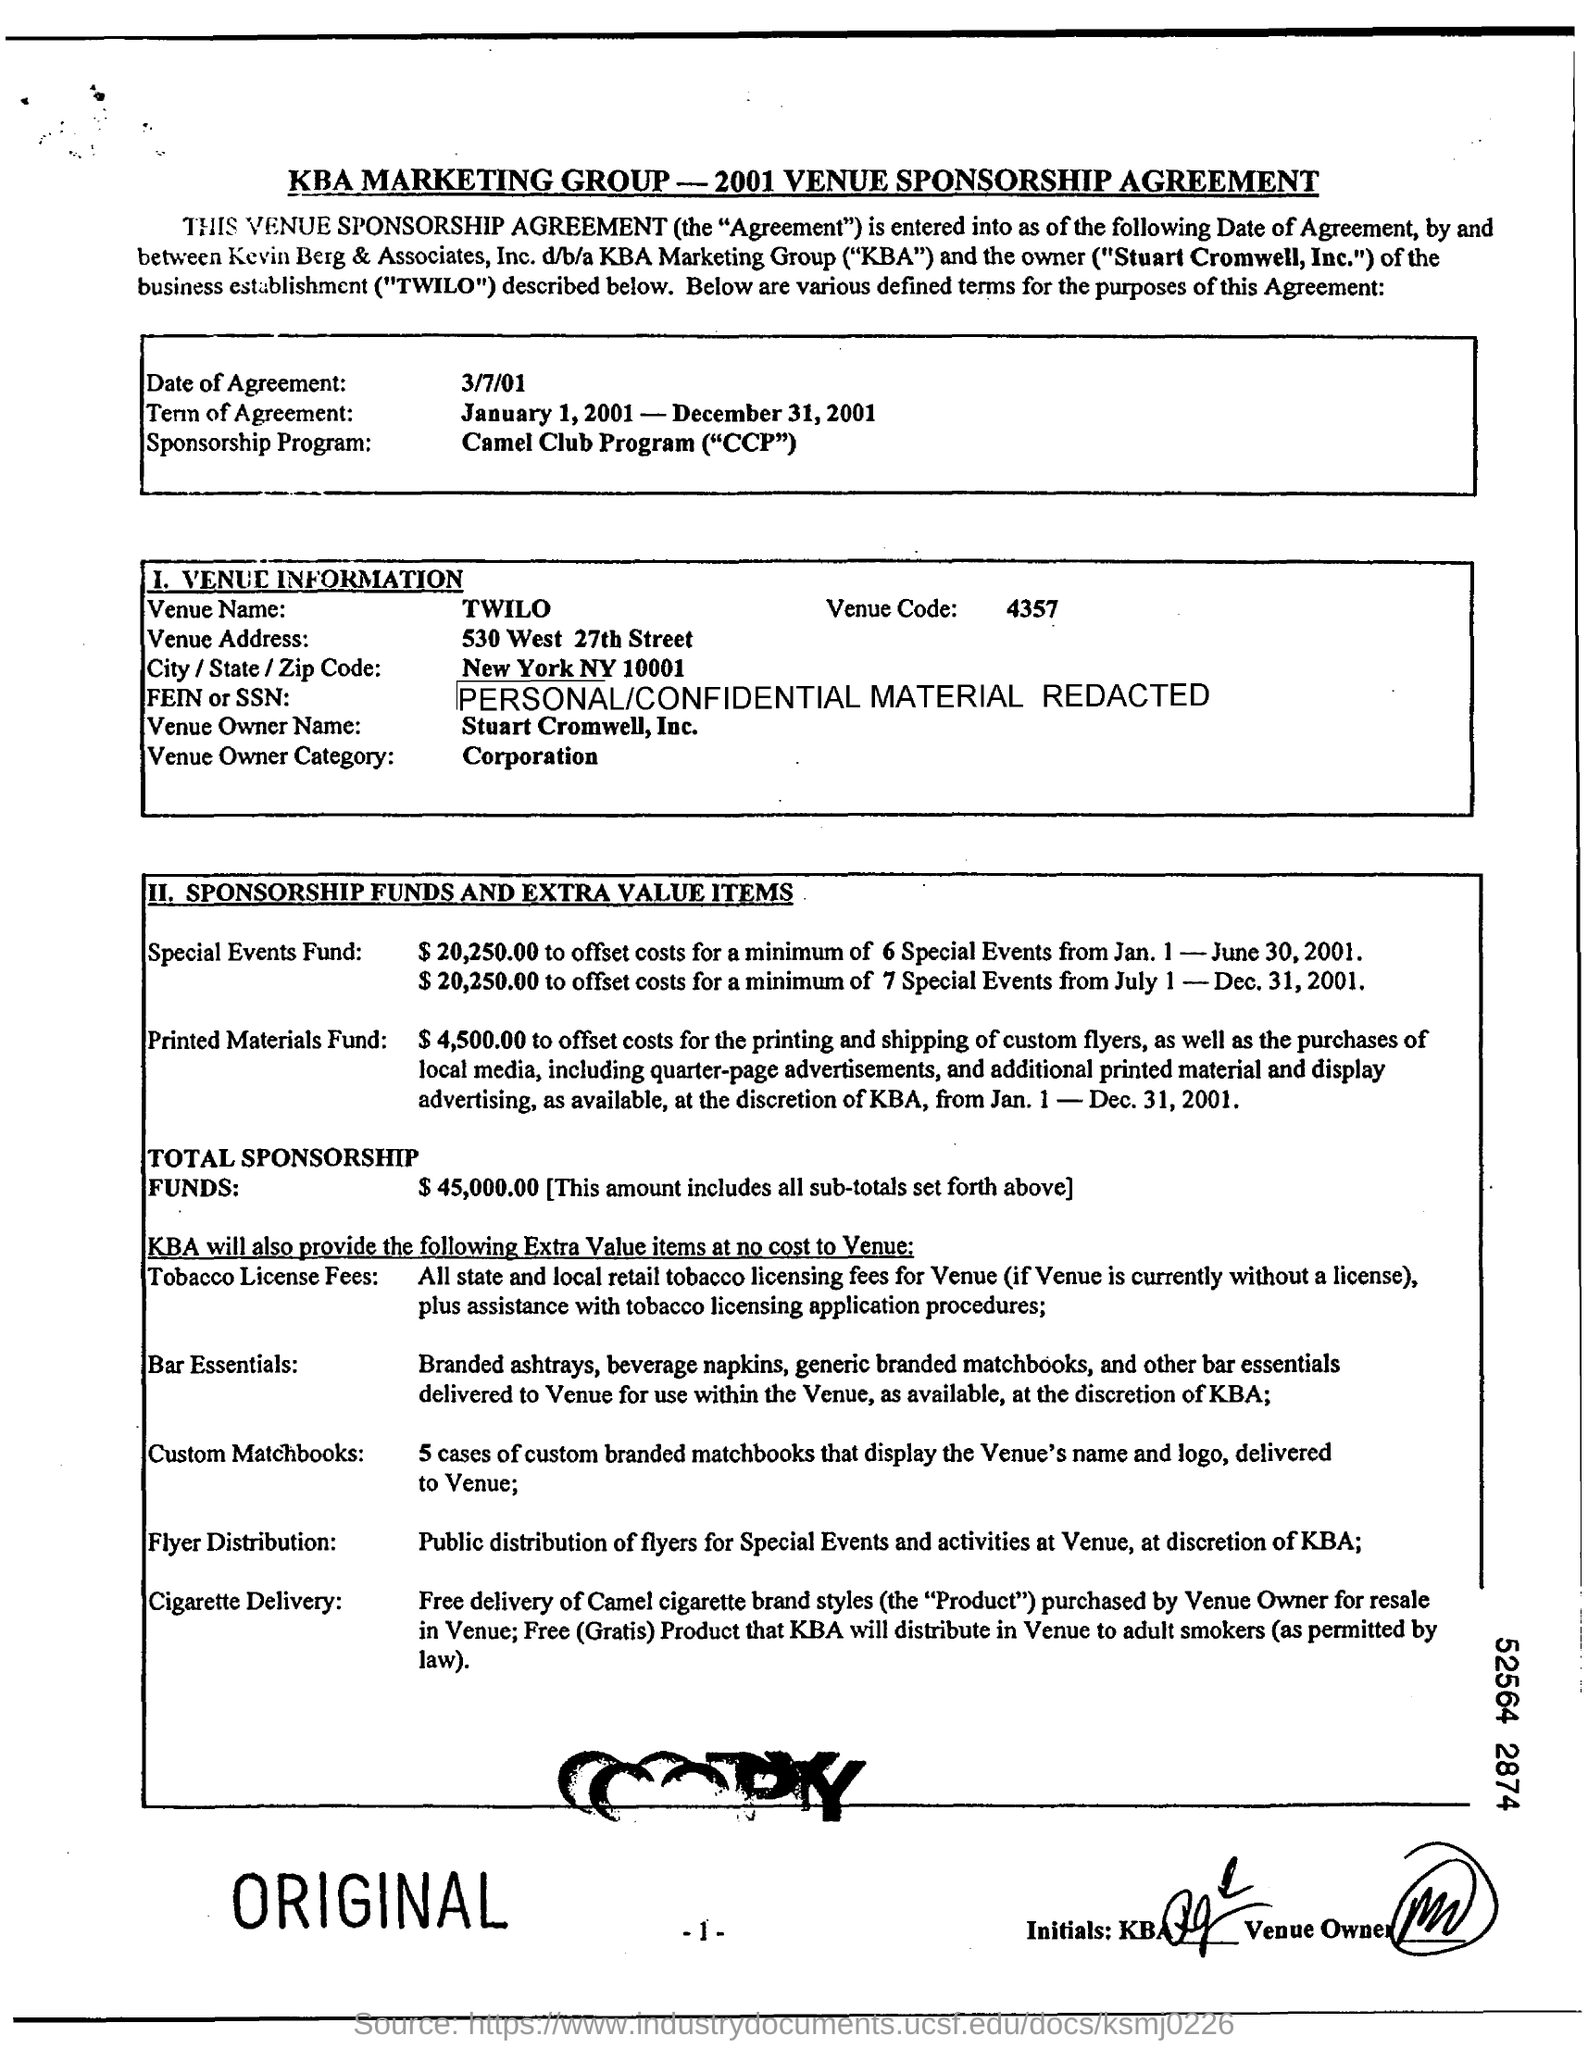Specify some key components in this picture. The total amount of sponsorship funds was $45,000.00. The venue code is 4357. The term of agreement started on January 1, 2001 and ended on December 31, 2001. The venue name is TWILO. 